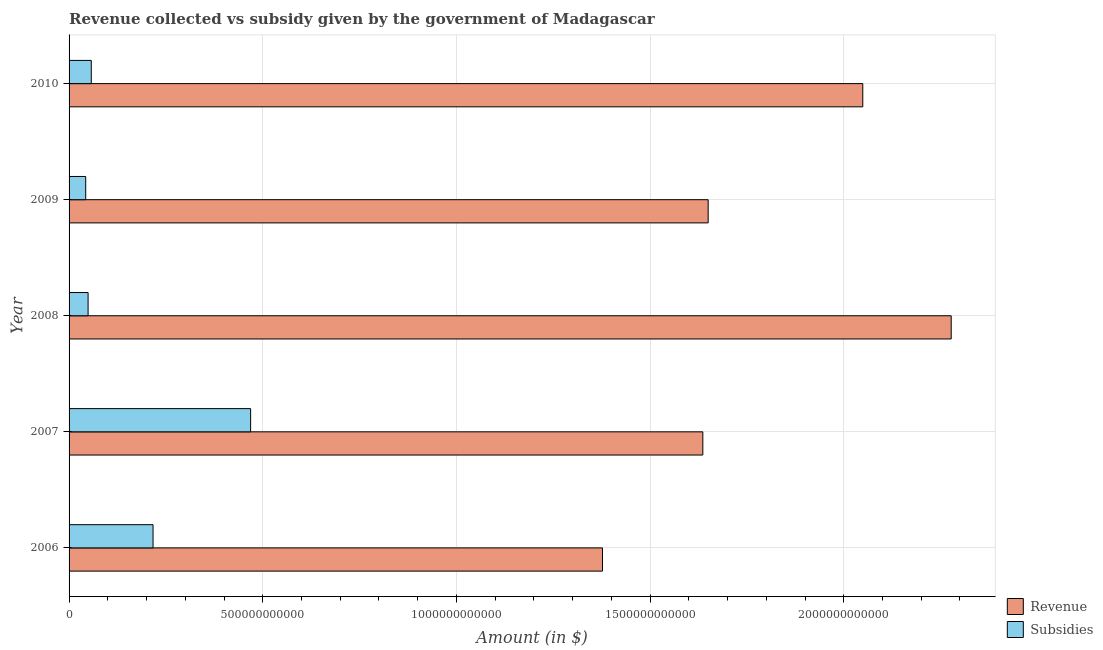How many different coloured bars are there?
Ensure brevity in your answer.  2. How many groups of bars are there?
Provide a succinct answer. 5. What is the amount of revenue collected in 2009?
Provide a succinct answer. 1.65e+12. Across all years, what is the maximum amount of subsidies given?
Ensure brevity in your answer.  4.69e+11. Across all years, what is the minimum amount of revenue collected?
Your answer should be compact. 1.38e+12. What is the total amount of revenue collected in the graph?
Offer a terse response. 8.99e+12. What is the difference between the amount of subsidies given in 2007 and that in 2010?
Provide a short and direct response. 4.11e+11. What is the difference between the amount of subsidies given in 2010 and the amount of revenue collected in 2009?
Give a very brief answer. -1.59e+12. What is the average amount of revenue collected per year?
Keep it short and to the point. 1.80e+12. In the year 2007, what is the difference between the amount of subsidies given and amount of revenue collected?
Provide a short and direct response. -1.17e+12. In how many years, is the amount of subsidies given greater than 300000000000 $?
Ensure brevity in your answer.  1. What is the ratio of the amount of subsidies given in 2007 to that in 2010?
Ensure brevity in your answer.  8.17. Is the amount of revenue collected in 2006 less than that in 2007?
Make the answer very short. Yes. Is the difference between the amount of subsidies given in 2006 and 2008 greater than the difference between the amount of revenue collected in 2006 and 2008?
Offer a very short reply. Yes. What is the difference between the highest and the second highest amount of subsidies given?
Give a very brief answer. 2.52e+11. What is the difference between the highest and the lowest amount of revenue collected?
Offer a terse response. 9.00e+11. Is the sum of the amount of revenue collected in 2008 and 2009 greater than the maximum amount of subsidies given across all years?
Ensure brevity in your answer.  Yes. What does the 2nd bar from the top in 2007 represents?
Give a very brief answer. Revenue. What does the 1st bar from the bottom in 2010 represents?
Give a very brief answer. Revenue. What is the difference between two consecutive major ticks on the X-axis?
Provide a short and direct response. 5.00e+11. Are the values on the major ticks of X-axis written in scientific E-notation?
Offer a very short reply. No. Does the graph contain any zero values?
Your answer should be compact. No. What is the title of the graph?
Your answer should be compact. Revenue collected vs subsidy given by the government of Madagascar. What is the label or title of the X-axis?
Provide a succinct answer. Amount (in $). What is the Amount (in $) in Revenue in 2006?
Provide a succinct answer. 1.38e+12. What is the Amount (in $) in Subsidies in 2006?
Give a very brief answer. 2.17e+11. What is the Amount (in $) in Revenue in 2007?
Offer a very short reply. 1.64e+12. What is the Amount (in $) of Subsidies in 2007?
Provide a succinct answer. 4.69e+11. What is the Amount (in $) of Revenue in 2008?
Your response must be concise. 2.28e+12. What is the Amount (in $) of Subsidies in 2008?
Your response must be concise. 4.91e+1. What is the Amount (in $) of Revenue in 2009?
Give a very brief answer. 1.65e+12. What is the Amount (in $) in Subsidies in 2009?
Offer a terse response. 4.29e+1. What is the Amount (in $) of Revenue in 2010?
Provide a short and direct response. 2.05e+12. What is the Amount (in $) of Subsidies in 2010?
Keep it short and to the point. 5.74e+1. Across all years, what is the maximum Amount (in $) in Revenue?
Your answer should be compact. 2.28e+12. Across all years, what is the maximum Amount (in $) in Subsidies?
Offer a very short reply. 4.69e+11. Across all years, what is the minimum Amount (in $) in Revenue?
Make the answer very short. 1.38e+12. Across all years, what is the minimum Amount (in $) of Subsidies?
Offer a very short reply. 4.29e+1. What is the total Amount (in $) in Revenue in the graph?
Your answer should be very brief. 8.99e+12. What is the total Amount (in $) in Subsidies in the graph?
Ensure brevity in your answer.  8.35e+11. What is the difference between the Amount (in $) in Revenue in 2006 and that in 2007?
Provide a short and direct response. -2.59e+11. What is the difference between the Amount (in $) in Subsidies in 2006 and that in 2007?
Ensure brevity in your answer.  -2.52e+11. What is the difference between the Amount (in $) of Revenue in 2006 and that in 2008?
Your answer should be very brief. -9.00e+11. What is the difference between the Amount (in $) of Subsidies in 2006 and that in 2008?
Your answer should be compact. 1.68e+11. What is the difference between the Amount (in $) in Revenue in 2006 and that in 2009?
Provide a short and direct response. -2.73e+11. What is the difference between the Amount (in $) of Subsidies in 2006 and that in 2009?
Ensure brevity in your answer.  1.74e+11. What is the difference between the Amount (in $) of Revenue in 2006 and that in 2010?
Provide a succinct answer. -6.72e+11. What is the difference between the Amount (in $) in Subsidies in 2006 and that in 2010?
Make the answer very short. 1.59e+11. What is the difference between the Amount (in $) in Revenue in 2007 and that in 2008?
Your answer should be compact. -6.41e+11. What is the difference between the Amount (in $) in Subsidies in 2007 and that in 2008?
Your answer should be compact. 4.20e+11. What is the difference between the Amount (in $) in Revenue in 2007 and that in 2009?
Provide a succinct answer. -1.38e+1. What is the difference between the Amount (in $) of Subsidies in 2007 and that in 2009?
Give a very brief answer. 4.26e+11. What is the difference between the Amount (in $) of Revenue in 2007 and that in 2010?
Your answer should be very brief. -4.13e+11. What is the difference between the Amount (in $) in Subsidies in 2007 and that in 2010?
Make the answer very short. 4.11e+11. What is the difference between the Amount (in $) of Revenue in 2008 and that in 2009?
Your answer should be compact. 6.27e+11. What is the difference between the Amount (in $) in Subsidies in 2008 and that in 2009?
Keep it short and to the point. 6.17e+09. What is the difference between the Amount (in $) in Revenue in 2008 and that in 2010?
Ensure brevity in your answer.  2.28e+11. What is the difference between the Amount (in $) of Subsidies in 2008 and that in 2010?
Offer a terse response. -8.26e+09. What is the difference between the Amount (in $) of Revenue in 2009 and that in 2010?
Ensure brevity in your answer.  -3.99e+11. What is the difference between the Amount (in $) of Subsidies in 2009 and that in 2010?
Give a very brief answer. -1.44e+1. What is the difference between the Amount (in $) of Revenue in 2006 and the Amount (in $) of Subsidies in 2007?
Provide a succinct answer. 9.08e+11. What is the difference between the Amount (in $) of Revenue in 2006 and the Amount (in $) of Subsidies in 2008?
Make the answer very short. 1.33e+12. What is the difference between the Amount (in $) of Revenue in 2006 and the Amount (in $) of Subsidies in 2009?
Ensure brevity in your answer.  1.33e+12. What is the difference between the Amount (in $) of Revenue in 2006 and the Amount (in $) of Subsidies in 2010?
Give a very brief answer. 1.32e+12. What is the difference between the Amount (in $) of Revenue in 2007 and the Amount (in $) of Subsidies in 2008?
Provide a short and direct response. 1.59e+12. What is the difference between the Amount (in $) of Revenue in 2007 and the Amount (in $) of Subsidies in 2009?
Your response must be concise. 1.59e+12. What is the difference between the Amount (in $) of Revenue in 2007 and the Amount (in $) of Subsidies in 2010?
Keep it short and to the point. 1.58e+12. What is the difference between the Amount (in $) of Revenue in 2008 and the Amount (in $) of Subsidies in 2009?
Make the answer very short. 2.23e+12. What is the difference between the Amount (in $) in Revenue in 2008 and the Amount (in $) in Subsidies in 2010?
Give a very brief answer. 2.22e+12. What is the difference between the Amount (in $) in Revenue in 2009 and the Amount (in $) in Subsidies in 2010?
Keep it short and to the point. 1.59e+12. What is the average Amount (in $) in Revenue per year?
Make the answer very short. 1.80e+12. What is the average Amount (in $) of Subsidies per year?
Your response must be concise. 1.67e+11. In the year 2006, what is the difference between the Amount (in $) of Revenue and Amount (in $) of Subsidies?
Offer a very short reply. 1.16e+12. In the year 2007, what is the difference between the Amount (in $) in Revenue and Amount (in $) in Subsidies?
Your answer should be compact. 1.17e+12. In the year 2008, what is the difference between the Amount (in $) of Revenue and Amount (in $) of Subsidies?
Your answer should be very brief. 2.23e+12. In the year 2009, what is the difference between the Amount (in $) in Revenue and Amount (in $) in Subsidies?
Make the answer very short. 1.61e+12. In the year 2010, what is the difference between the Amount (in $) of Revenue and Amount (in $) of Subsidies?
Offer a very short reply. 1.99e+12. What is the ratio of the Amount (in $) in Revenue in 2006 to that in 2007?
Give a very brief answer. 0.84. What is the ratio of the Amount (in $) of Subsidies in 2006 to that in 2007?
Keep it short and to the point. 0.46. What is the ratio of the Amount (in $) in Revenue in 2006 to that in 2008?
Provide a short and direct response. 0.6. What is the ratio of the Amount (in $) of Subsidies in 2006 to that in 2008?
Your answer should be very brief. 4.42. What is the ratio of the Amount (in $) in Revenue in 2006 to that in 2009?
Give a very brief answer. 0.83. What is the ratio of the Amount (in $) of Subsidies in 2006 to that in 2009?
Provide a succinct answer. 5.05. What is the ratio of the Amount (in $) of Revenue in 2006 to that in 2010?
Your response must be concise. 0.67. What is the ratio of the Amount (in $) of Subsidies in 2006 to that in 2010?
Keep it short and to the point. 3.78. What is the ratio of the Amount (in $) in Revenue in 2007 to that in 2008?
Your response must be concise. 0.72. What is the ratio of the Amount (in $) in Subsidies in 2007 to that in 2008?
Offer a terse response. 9.55. What is the ratio of the Amount (in $) of Subsidies in 2007 to that in 2009?
Keep it short and to the point. 10.92. What is the ratio of the Amount (in $) of Revenue in 2007 to that in 2010?
Your answer should be very brief. 0.8. What is the ratio of the Amount (in $) in Subsidies in 2007 to that in 2010?
Give a very brief answer. 8.17. What is the ratio of the Amount (in $) in Revenue in 2008 to that in 2009?
Give a very brief answer. 1.38. What is the ratio of the Amount (in $) of Subsidies in 2008 to that in 2009?
Your response must be concise. 1.14. What is the ratio of the Amount (in $) in Revenue in 2008 to that in 2010?
Your answer should be very brief. 1.11. What is the ratio of the Amount (in $) of Subsidies in 2008 to that in 2010?
Provide a succinct answer. 0.86. What is the ratio of the Amount (in $) of Revenue in 2009 to that in 2010?
Your answer should be very brief. 0.81. What is the ratio of the Amount (in $) of Subsidies in 2009 to that in 2010?
Your answer should be very brief. 0.75. What is the difference between the highest and the second highest Amount (in $) in Revenue?
Give a very brief answer. 2.28e+11. What is the difference between the highest and the second highest Amount (in $) of Subsidies?
Your answer should be compact. 2.52e+11. What is the difference between the highest and the lowest Amount (in $) of Revenue?
Give a very brief answer. 9.00e+11. What is the difference between the highest and the lowest Amount (in $) in Subsidies?
Your answer should be very brief. 4.26e+11. 